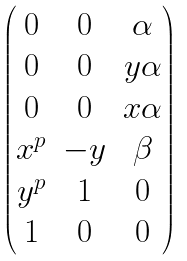<formula> <loc_0><loc_0><loc_500><loc_500>\begin{pmatrix} 0 & 0 & \alpha \\ 0 & 0 & y \alpha \\ 0 & 0 & x \alpha \\ x ^ { p } & - y & \beta \\ y ^ { p } & 1 & 0 \\ 1 & 0 & 0 \end{pmatrix}</formula> 